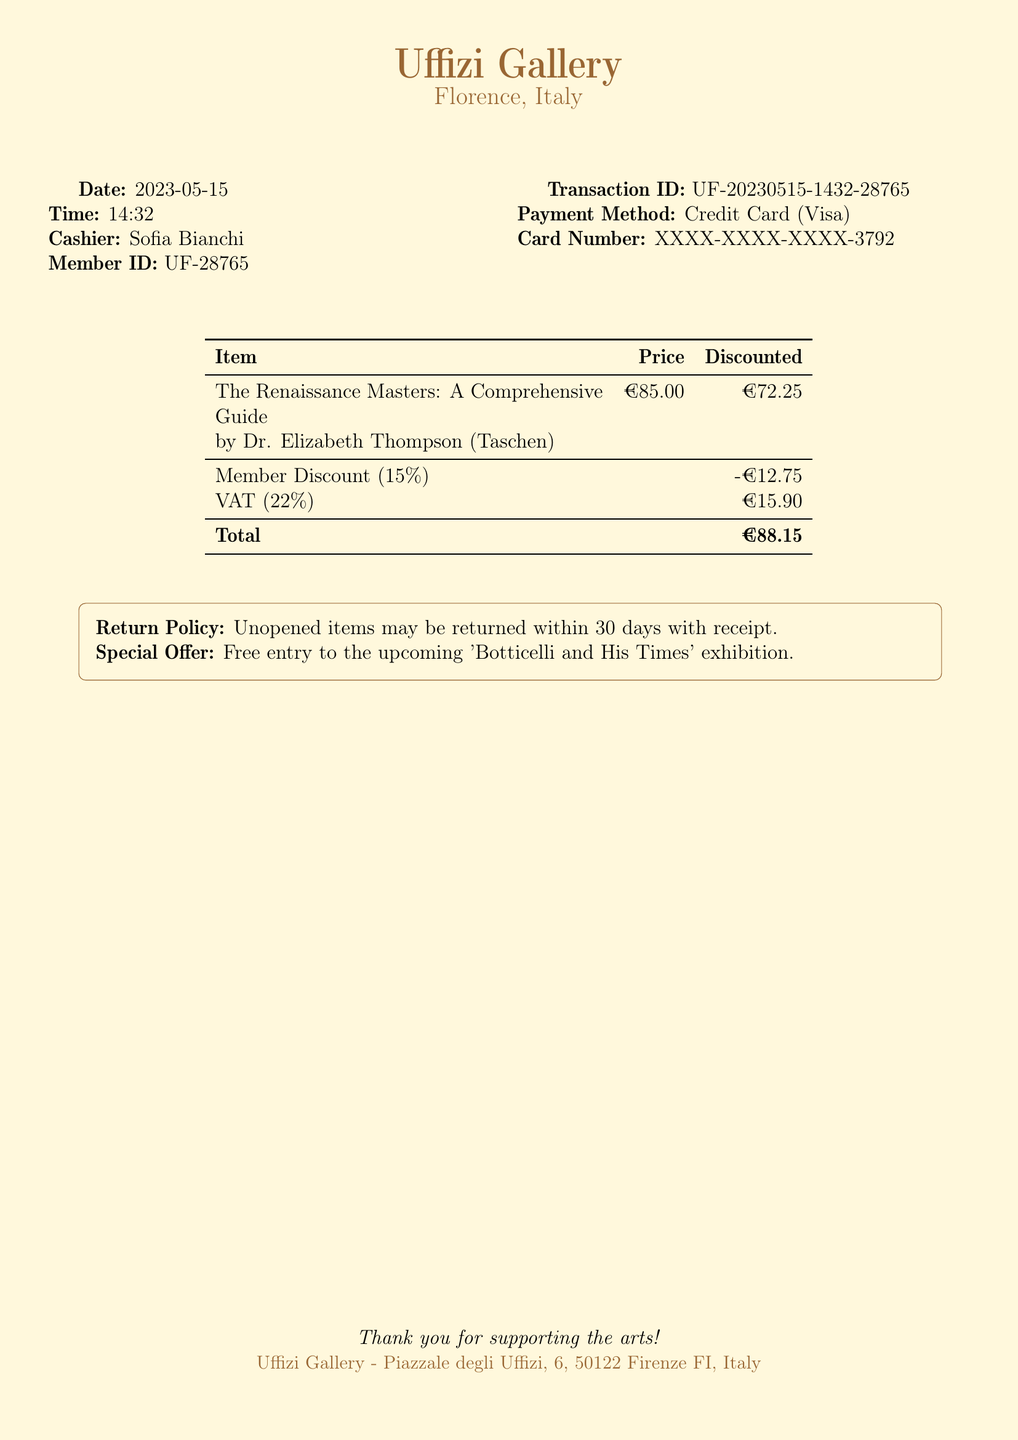what is the date of the transaction? The date of the transaction is explicitly mentioned in the document under the "Date" section.
Answer: 2023-05-15 who was the cashier? The cashier's name is stated in the document, clearly labeled under the "Cashier" section.
Answer: Sofia Bianchi what is the total amount paid? The total amount paid is listed at the bottom of the table, under the "Total" row.
Answer: €88.15 what discount was applied to the item? The member discount is detailed in the document and shown before the VAT calculation.
Answer: -€12.75 how much VAT was charged? The VAT amount is displayed in the document, specifically noted after the member discount.
Answer: €15.90 what is the title of the book purchased? The title of the book is prominently stated in the item description within the table.
Answer: The Renaissance Masters: A Comprehensive Guide what is the percentage of the member discount? The document states the percentage next to the member discount entry in the table.
Answer: 15% what is the return policy for the purchased item? The return policy is included in a note and outlines the terms for returning items.
Answer: Unopened items may be returned within 30 days with receipt what special offer is mentioned? The document includes a special offer below the return policy related to an upcoming exhibition.
Answer: Free entry to the upcoming 'Botticelli and His Times' exhibition 